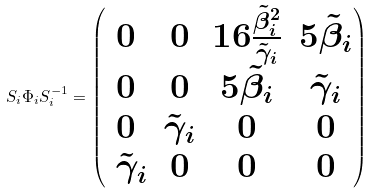Convert formula to latex. <formula><loc_0><loc_0><loc_500><loc_500>S _ { i } \Phi _ { i } S _ { i } ^ { - 1 } = \begin{pmatrix} 0 & 0 & 1 6 \frac { \tilde { \beta } ^ { 2 } _ { i } } { \tilde { \gamma } _ { i } } & 5 \tilde { \beta } _ { i } \\ 0 & 0 & 5 \tilde { \beta } _ { i } & \tilde { \gamma } _ { i } \\ 0 & \tilde { \gamma } _ { i } & 0 & 0 \\ \ \tilde { \gamma } _ { i } & 0 & 0 & 0 \end{pmatrix}</formula> 